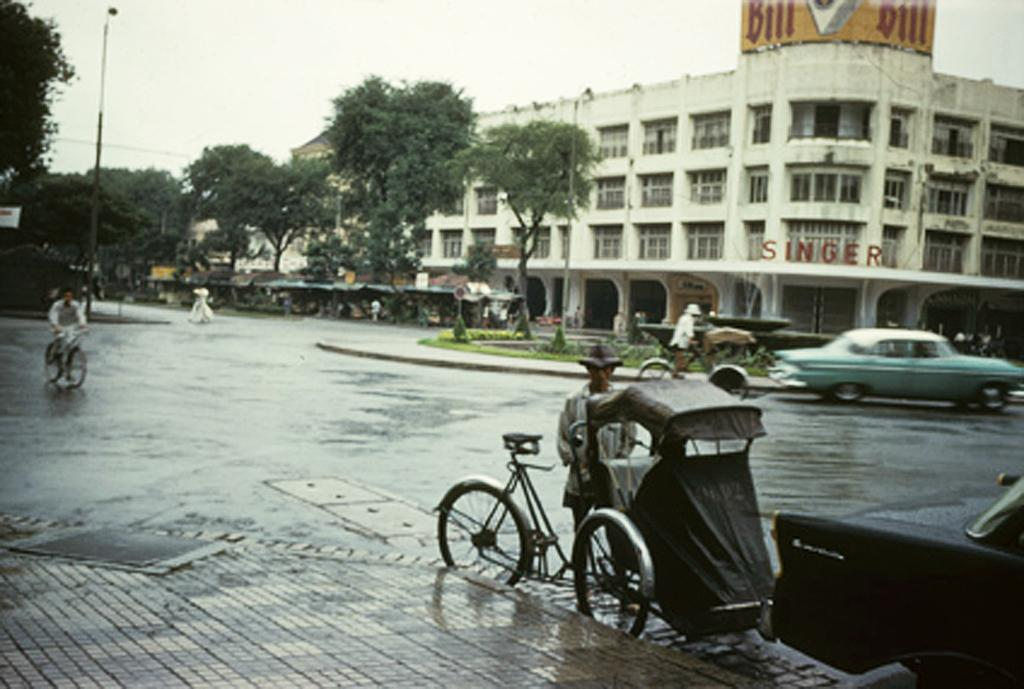What type of structures can be seen in the image? There are buildings in the image. What other natural or man-made elements can be seen in the image? There are trees, stalls on the road, a fountain, and street poles visible in the image. What are the people in the image using for transportation? Persons riding bicycles and motor vehicles are present on the road in the image. What is the purpose of the name board in the image? The name board in the image might indicate the name of a place or establishment. What is visible in the sky in the image? The sky is visible in the image. How many pizzas are being served at the ground in the image? There are no pizzas or ground visible in the image. Can you describe the sofa in the image? There is no sofa present in the image. 